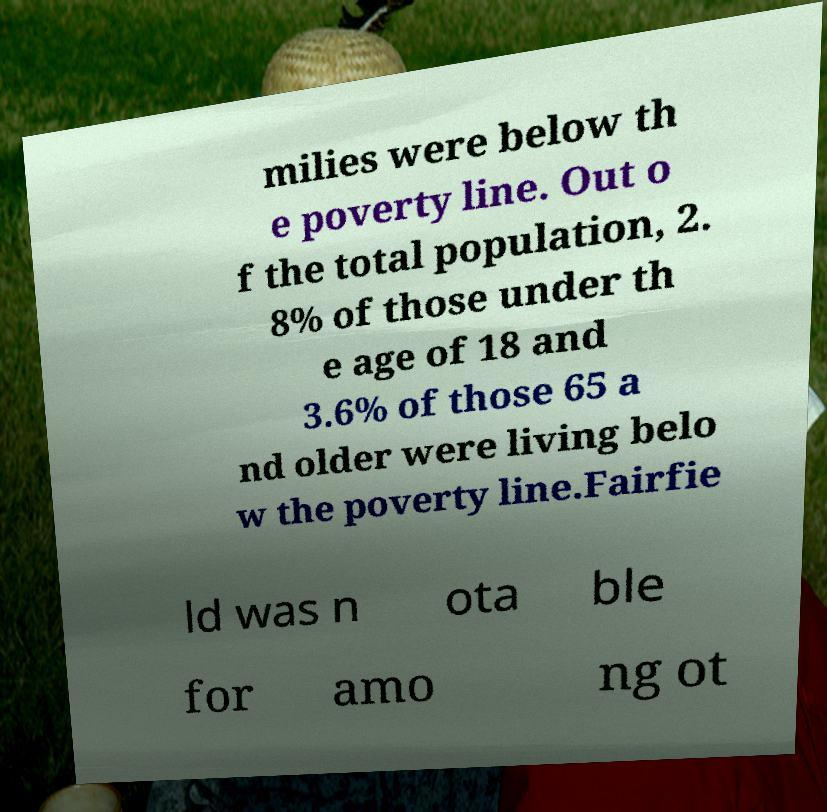Can you accurately transcribe the text from the provided image for me? milies were below th e poverty line. Out o f the total population, 2. 8% of those under th e age of 18 and 3.6% of those 65 a nd older were living belo w the poverty line.Fairfie ld was n ota ble for amo ng ot 